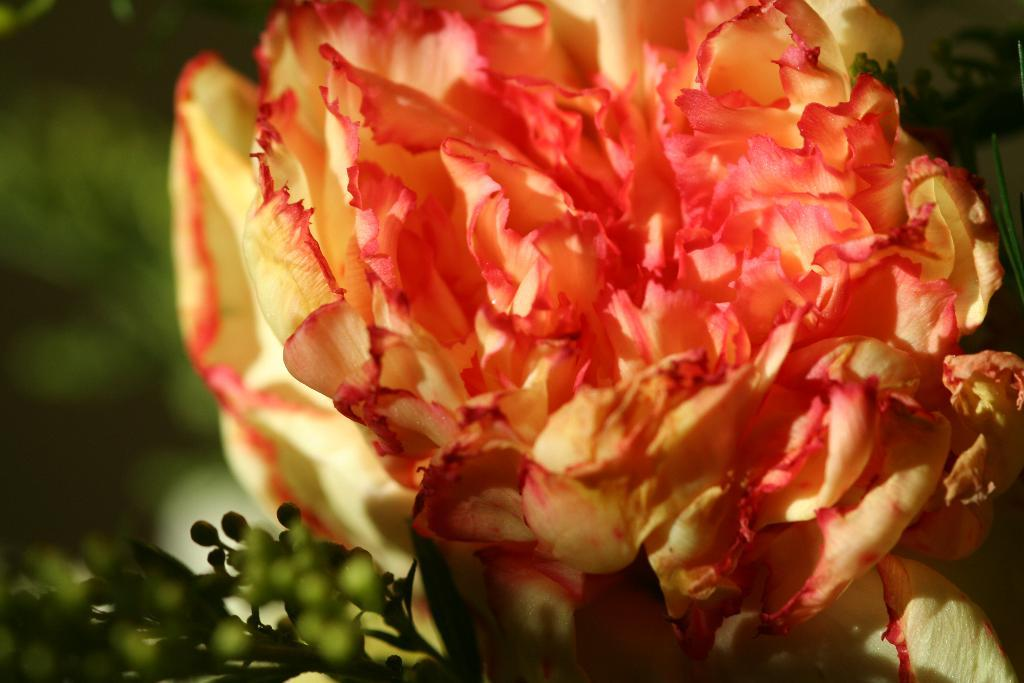What is the main subject of the image? There is a flower in the center of the image. Can you describe the flower in more detail? Unfortunately, the image does not provide enough detail to describe the flower further. Is there anything else visible in the image besides the flower? No, the facts provided only mention the presence of a flower in the image. What type of island can be seen in the background of the image? There is no island present in the image; it only features a flower in the center. 